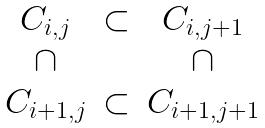Convert formula to latex. <formula><loc_0><loc_0><loc_500><loc_500>\begin{array} { c c c } C _ { i , j } & \subset & C _ { i , j + 1 } \\ \cap & & \cap \\ C _ { i + 1 , j } & \subset & C _ { i + 1 , j + 1 } \end{array}</formula> 